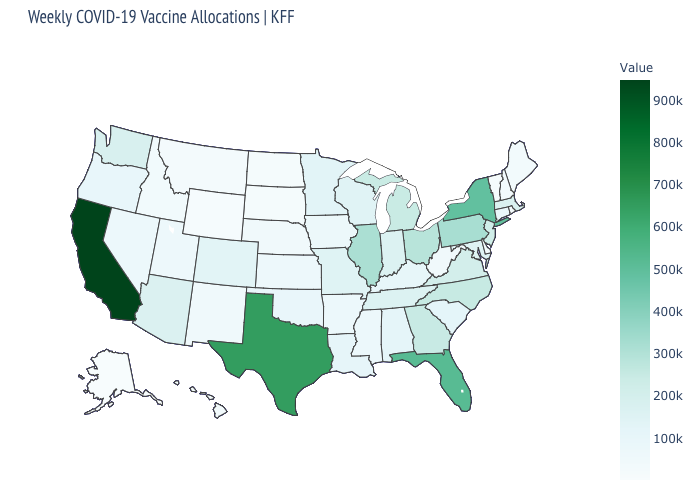Does the map have missing data?
Quick response, please. No. Which states have the lowest value in the West?
Be succinct. Alaska. Does Alaska have the lowest value in the USA?
Quick response, please. Yes. Which states have the lowest value in the USA?
Be succinct. Alaska. Is the legend a continuous bar?
Short answer required. Yes. 